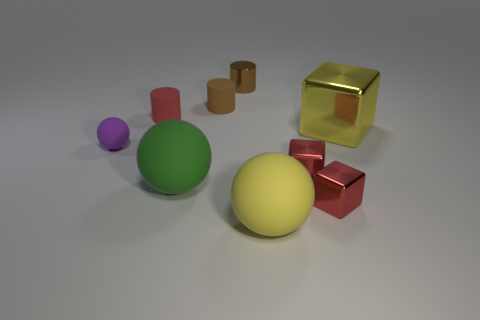Is the number of green matte balls that are behind the yellow shiny thing less than the number of green rubber objects?
Offer a very short reply. Yes. Is there a yellow matte object of the same size as the green rubber object?
Make the answer very short. Yes. The metal cylinder is what color?
Offer a very short reply. Brown. Is the green matte object the same size as the yellow matte ball?
Your response must be concise. Yes. What number of objects are either green balls or blocks?
Your answer should be very brief. 4. Is the number of rubber cylinders that are in front of the green sphere the same as the number of big purple objects?
Provide a succinct answer. Yes. There is a yellow thing to the left of the large yellow object behind the yellow matte ball; is there a large yellow cube on the right side of it?
Your answer should be very brief. Yes. What color is the small cylinder that is the same material as the yellow cube?
Provide a succinct answer. Brown. Does the small rubber cylinder that is right of the red matte cylinder have the same color as the metal cylinder?
Keep it short and to the point. Yes. How many balls are either big brown rubber objects or small shiny objects?
Provide a succinct answer. 0. 